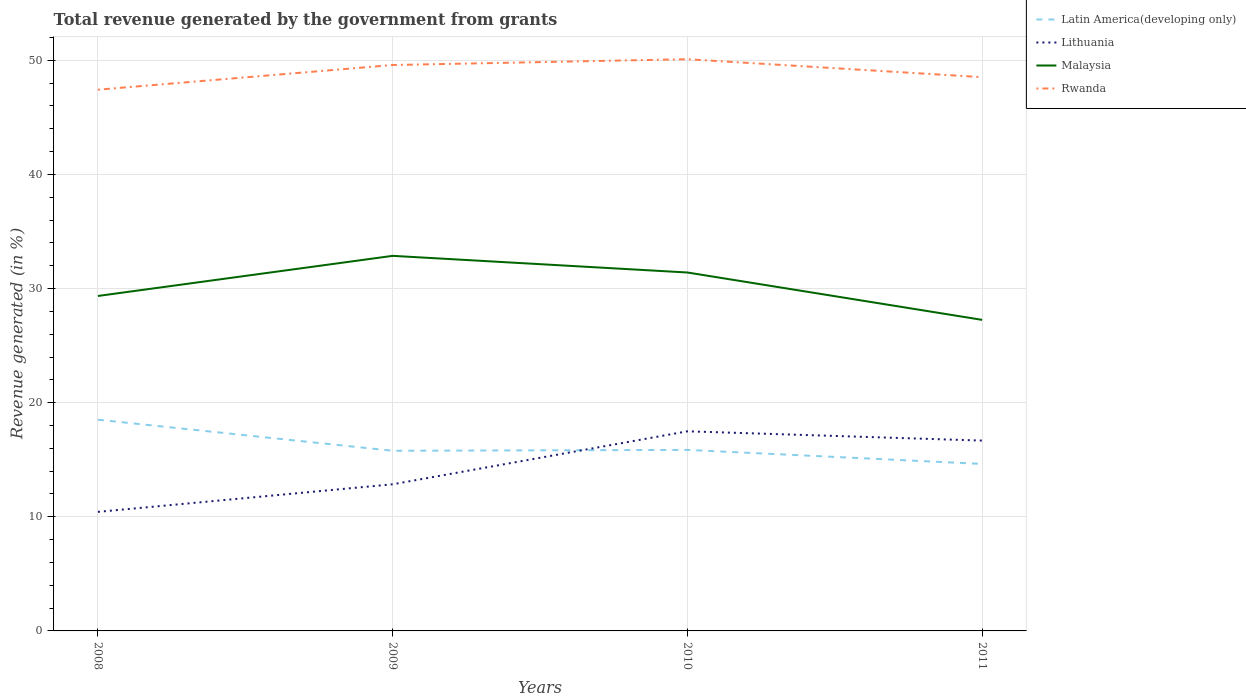Does the line corresponding to Malaysia intersect with the line corresponding to Rwanda?
Your answer should be very brief. No. Is the number of lines equal to the number of legend labels?
Give a very brief answer. Yes. Across all years, what is the maximum total revenue generated in Latin America(developing only)?
Your response must be concise. 14.63. In which year was the total revenue generated in Lithuania maximum?
Offer a very short reply. 2008. What is the total total revenue generated in Malaysia in the graph?
Your answer should be compact. 5.61. What is the difference between the highest and the second highest total revenue generated in Malaysia?
Give a very brief answer. 5.61. What is the difference between the highest and the lowest total revenue generated in Latin America(developing only)?
Offer a terse response. 1. How many lines are there?
Keep it short and to the point. 4. Are the values on the major ticks of Y-axis written in scientific E-notation?
Your answer should be compact. No. Does the graph contain any zero values?
Provide a succinct answer. No. Does the graph contain grids?
Your answer should be compact. Yes. How many legend labels are there?
Your answer should be very brief. 4. How are the legend labels stacked?
Your response must be concise. Vertical. What is the title of the graph?
Your response must be concise. Total revenue generated by the government from grants. What is the label or title of the Y-axis?
Your answer should be very brief. Revenue generated (in %). What is the Revenue generated (in %) of Latin America(developing only) in 2008?
Make the answer very short. 18.51. What is the Revenue generated (in %) in Lithuania in 2008?
Your answer should be very brief. 10.43. What is the Revenue generated (in %) in Malaysia in 2008?
Give a very brief answer. 29.35. What is the Revenue generated (in %) in Rwanda in 2008?
Your response must be concise. 47.42. What is the Revenue generated (in %) in Latin America(developing only) in 2009?
Your answer should be compact. 15.78. What is the Revenue generated (in %) of Lithuania in 2009?
Your answer should be very brief. 12.85. What is the Revenue generated (in %) in Malaysia in 2009?
Keep it short and to the point. 32.86. What is the Revenue generated (in %) in Rwanda in 2009?
Offer a terse response. 49.58. What is the Revenue generated (in %) of Latin America(developing only) in 2010?
Offer a very short reply. 15.86. What is the Revenue generated (in %) in Lithuania in 2010?
Make the answer very short. 17.49. What is the Revenue generated (in %) of Malaysia in 2010?
Offer a very short reply. 31.4. What is the Revenue generated (in %) in Rwanda in 2010?
Provide a succinct answer. 50.09. What is the Revenue generated (in %) in Latin America(developing only) in 2011?
Provide a short and direct response. 14.63. What is the Revenue generated (in %) of Lithuania in 2011?
Your response must be concise. 16.68. What is the Revenue generated (in %) in Malaysia in 2011?
Ensure brevity in your answer.  27.25. What is the Revenue generated (in %) in Rwanda in 2011?
Your answer should be very brief. 48.52. Across all years, what is the maximum Revenue generated (in %) of Latin America(developing only)?
Provide a succinct answer. 18.51. Across all years, what is the maximum Revenue generated (in %) in Lithuania?
Your answer should be very brief. 17.49. Across all years, what is the maximum Revenue generated (in %) of Malaysia?
Make the answer very short. 32.86. Across all years, what is the maximum Revenue generated (in %) in Rwanda?
Provide a succinct answer. 50.09. Across all years, what is the minimum Revenue generated (in %) in Latin America(developing only)?
Your answer should be compact. 14.63. Across all years, what is the minimum Revenue generated (in %) in Lithuania?
Provide a succinct answer. 10.43. Across all years, what is the minimum Revenue generated (in %) in Malaysia?
Offer a very short reply. 27.25. Across all years, what is the minimum Revenue generated (in %) of Rwanda?
Your answer should be compact. 47.42. What is the total Revenue generated (in %) of Latin America(developing only) in the graph?
Keep it short and to the point. 64.78. What is the total Revenue generated (in %) in Lithuania in the graph?
Give a very brief answer. 57.45. What is the total Revenue generated (in %) in Malaysia in the graph?
Provide a short and direct response. 120.87. What is the total Revenue generated (in %) in Rwanda in the graph?
Your response must be concise. 195.62. What is the difference between the Revenue generated (in %) in Latin America(developing only) in 2008 and that in 2009?
Your answer should be compact. 2.72. What is the difference between the Revenue generated (in %) in Lithuania in 2008 and that in 2009?
Give a very brief answer. -2.42. What is the difference between the Revenue generated (in %) of Malaysia in 2008 and that in 2009?
Give a very brief answer. -3.52. What is the difference between the Revenue generated (in %) in Rwanda in 2008 and that in 2009?
Make the answer very short. -2.16. What is the difference between the Revenue generated (in %) in Latin America(developing only) in 2008 and that in 2010?
Your answer should be very brief. 2.65. What is the difference between the Revenue generated (in %) in Lithuania in 2008 and that in 2010?
Give a very brief answer. -7.06. What is the difference between the Revenue generated (in %) of Malaysia in 2008 and that in 2010?
Offer a very short reply. -2.06. What is the difference between the Revenue generated (in %) of Rwanda in 2008 and that in 2010?
Keep it short and to the point. -2.67. What is the difference between the Revenue generated (in %) of Latin America(developing only) in 2008 and that in 2011?
Make the answer very short. 3.88. What is the difference between the Revenue generated (in %) of Lithuania in 2008 and that in 2011?
Provide a short and direct response. -6.24. What is the difference between the Revenue generated (in %) of Malaysia in 2008 and that in 2011?
Give a very brief answer. 2.09. What is the difference between the Revenue generated (in %) of Rwanda in 2008 and that in 2011?
Give a very brief answer. -1.1. What is the difference between the Revenue generated (in %) in Latin America(developing only) in 2009 and that in 2010?
Give a very brief answer. -0.08. What is the difference between the Revenue generated (in %) in Lithuania in 2009 and that in 2010?
Make the answer very short. -4.64. What is the difference between the Revenue generated (in %) of Malaysia in 2009 and that in 2010?
Offer a very short reply. 1.46. What is the difference between the Revenue generated (in %) of Rwanda in 2009 and that in 2010?
Ensure brevity in your answer.  -0.51. What is the difference between the Revenue generated (in %) in Latin America(developing only) in 2009 and that in 2011?
Your answer should be compact. 1.15. What is the difference between the Revenue generated (in %) of Lithuania in 2009 and that in 2011?
Your answer should be compact. -3.83. What is the difference between the Revenue generated (in %) in Malaysia in 2009 and that in 2011?
Offer a very short reply. 5.61. What is the difference between the Revenue generated (in %) in Rwanda in 2009 and that in 2011?
Your answer should be compact. 1.06. What is the difference between the Revenue generated (in %) of Latin America(developing only) in 2010 and that in 2011?
Provide a short and direct response. 1.23. What is the difference between the Revenue generated (in %) in Lithuania in 2010 and that in 2011?
Give a very brief answer. 0.81. What is the difference between the Revenue generated (in %) of Malaysia in 2010 and that in 2011?
Keep it short and to the point. 4.15. What is the difference between the Revenue generated (in %) in Rwanda in 2010 and that in 2011?
Your answer should be very brief. 1.57. What is the difference between the Revenue generated (in %) in Latin America(developing only) in 2008 and the Revenue generated (in %) in Lithuania in 2009?
Provide a short and direct response. 5.66. What is the difference between the Revenue generated (in %) of Latin America(developing only) in 2008 and the Revenue generated (in %) of Malaysia in 2009?
Make the answer very short. -14.36. What is the difference between the Revenue generated (in %) of Latin America(developing only) in 2008 and the Revenue generated (in %) of Rwanda in 2009?
Keep it short and to the point. -31.08. What is the difference between the Revenue generated (in %) in Lithuania in 2008 and the Revenue generated (in %) in Malaysia in 2009?
Offer a terse response. -22.43. What is the difference between the Revenue generated (in %) in Lithuania in 2008 and the Revenue generated (in %) in Rwanda in 2009?
Keep it short and to the point. -39.15. What is the difference between the Revenue generated (in %) in Malaysia in 2008 and the Revenue generated (in %) in Rwanda in 2009?
Make the answer very short. -20.24. What is the difference between the Revenue generated (in %) of Latin America(developing only) in 2008 and the Revenue generated (in %) of Lithuania in 2010?
Keep it short and to the point. 1.02. What is the difference between the Revenue generated (in %) of Latin America(developing only) in 2008 and the Revenue generated (in %) of Malaysia in 2010?
Your answer should be compact. -12.9. What is the difference between the Revenue generated (in %) in Latin America(developing only) in 2008 and the Revenue generated (in %) in Rwanda in 2010?
Provide a succinct answer. -31.59. What is the difference between the Revenue generated (in %) in Lithuania in 2008 and the Revenue generated (in %) in Malaysia in 2010?
Make the answer very short. -20.97. What is the difference between the Revenue generated (in %) of Lithuania in 2008 and the Revenue generated (in %) of Rwanda in 2010?
Your response must be concise. -39.66. What is the difference between the Revenue generated (in %) of Malaysia in 2008 and the Revenue generated (in %) of Rwanda in 2010?
Offer a very short reply. -20.74. What is the difference between the Revenue generated (in %) of Latin America(developing only) in 2008 and the Revenue generated (in %) of Lithuania in 2011?
Keep it short and to the point. 1.83. What is the difference between the Revenue generated (in %) of Latin America(developing only) in 2008 and the Revenue generated (in %) of Malaysia in 2011?
Give a very brief answer. -8.75. What is the difference between the Revenue generated (in %) in Latin America(developing only) in 2008 and the Revenue generated (in %) in Rwanda in 2011?
Provide a short and direct response. -30.01. What is the difference between the Revenue generated (in %) of Lithuania in 2008 and the Revenue generated (in %) of Malaysia in 2011?
Your response must be concise. -16.82. What is the difference between the Revenue generated (in %) in Lithuania in 2008 and the Revenue generated (in %) in Rwanda in 2011?
Your answer should be compact. -38.09. What is the difference between the Revenue generated (in %) of Malaysia in 2008 and the Revenue generated (in %) of Rwanda in 2011?
Your answer should be very brief. -19.17. What is the difference between the Revenue generated (in %) in Latin America(developing only) in 2009 and the Revenue generated (in %) in Lithuania in 2010?
Make the answer very short. -1.71. What is the difference between the Revenue generated (in %) of Latin America(developing only) in 2009 and the Revenue generated (in %) of Malaysia in 2010?
Offer a very short reply. -15.62. What is the difference between the Revenue generated (in %) in Latin America(developing only) in 2009 and the Revenue generated (in %) in Rwanda in 2010?
Ensure brevity in your answer.  -34.31. What is the difference between the Revenue generated (in %) of Lithuania in 2009 and the Revenue generated (in %) of Malaysia in 2010?
Your response must be concise. -18.56. What is the difference between the Revenue generated (in %) in Lithuania in 2009 and the Revenue generated (in %) in Rwanda in 2010?
Make the answer very short. -37.24. What is the difference between the Revenue generated (in %) in Malaysia in 2009 and the Revenue generated (in %) in Rwanda in 2010?
Give a very brief answer. -17.23. What is the difference between the Revenue generated (in %) of Latin America(developing only) in 2009 and the Revenue generated (in %) of Lithuania in 2011?
Keep it short and to the point. -0.89. What is the difference between the Revenue generated (in %) in Latin America(developing only) in 2009 and the Revenue generated (in %) in Malaysia in 2011?
Your answer should be very brief. -11.47. What is the difference between the Revenue generated (in %) of Latin America(developing only) in 2009 and the Revenue generated (in %) of Rwanda in 2011?
Your answer should be compact. -32.73. What is the difference between the Revenue generated (in %) in Lithuania in 2009 and the Revenue generated (in %) in Malaysia in 2011?
Keep it short and to the point. -14.41. What is the difference between the Revenue generated (in %) in Lithuania in 2009 and the Revenue generated (in %) in Rwanda in 2011?
Provide a succinct answer. -35.67. What is the difference between the Revenue generated (in %) in Malaysia in 2009 and the Revenue generated (in %) in Rwanda in 2011?
Offer a terse response. -15.65. What is the difference between the Revenue generated (in %) in Latin America(developing only) in 2010 and the Revenue generated (in %) in Lithuania in 2011?
Ensure brevity in your answer.  -0.81. What is the difference between the Revenue generated (in %) of Latin America(developing only) in 2010 and the Revenue generated (in %) of Malaysia in 2011?
Provide a succinct answer. -11.39. What is the difference between the Revenue generated (in %) of Latin America(developing only) in 2010 and the Revenue generated (in %) of Rwanda in 2011?
Offer a very short reply. -32.66. What is the difference between the Revenue generated (in %) in Lithuania in 2010 and the Revenue generated (in %) in Malaysia in 2011?
Offer a very short reply. -9.76. What is the difference between the Revenue generated (in %) in Lithuania in 2010 and the Revenue generated (in %) in Rwanda in 2011?
Offer a very short reply. -31.03. What is the difference between the Revenue generated (in %) of Malaysia in 2010 and the Revenue generated (in %) of Rwanda in 2011?
Provide a short and direct response. -17.11. What is the average Revenue generated (in %) of Latin America(developing only) per year?
Your answer should be compact. 16.2. What is the average Revenue generated (in %) of Lithuania per year?
Keep it short and to the point. 14.36. What is the average Revenue generated (in %) of Malaysia per year?
Your answer should be compact. 30.22. What is the average Revenue generated (in %) in Rwanda per year?
Offer a terse response. 48.9. In the year 2008, what is the difference between the Revenue generated (in %) of Latin America(developing only) and Revenue generated (in %) of Lithuania?
Offer a terse response. 8.08. In the year 2008, what is the difference between the Revenue generated (in %) in Latin America(developing only) and Revenue generated (in %) in Malaysia?
Offer a very short reply. -10.84. In the year 2008, what is the difference between the Revenue generated (in %) of Latin America(developing only) and Revenue generated (in %) of Rwanda?
Make the answer very short. -28.91. In the year 2008, what is the difference between the Revenue generated (in %) of Lithuania and Revenue generated (in %) of Malaysia?
Give a very brief answer. -18.92. In the year 2008, what is the difference between the Revenue generated (in %) of Lithuania and Revenue generated (in %) of Rwanda?
Provide a short and direct response. -36.99. In the year 2008, what is the difference between the Revenue generated (in %) in Malaysia and Revenue generated (in %) in Rwanda?
Offer a very short reply. -18.07. In the year 2009, what is the difference between the Revenue generated (in %) of Latin America(developing only) and Revenue generated (in %) of Lithuania?
Your answer should be compact. 2.94. In the year 2009, what is the difference between the Revenue generated (in %) in Latin America(developing only) and Revenue generated (in %) in Malaysia?
Offer a very short reply. -17.08. In the year 2009, what is the difference between the Revenue generated (in %) of Latin America(developing only) and Revenue generated (in %) of Rwanda?
Offer a very short reply. -33.8. In the year 2009, what is the difference between the Revenue generated (in %) in Lithuania and Revenue generated (in %) in Malaysia?
Offer a terse response. -20.02. In the year 2009, what is the difference between the Revenue generated (in %) of Lithuania and Revenue generated (in %) of Rwanda?
Ensure brevity in your answer.  -36.74. In the year 2009, what is the difference between the Revenue generated (in %) of Malaysia and Revenue generated (in %) of Rwanda?
Your answer should be compact. -16.72. In the year 2010, what is the difference between the Revenue generated (in %) of Latin America(developing only) and Revenue generated (in %) of Lithuania?
Make the answer very short. -1.63. In the year 2010, what is the difference between the Revenue generated (in %) in Latin America(developing only) and Revenue generated (in %) in Malaysia?
Offer a terse response. -15.54. In the year 2010, what is the difference between the Revenue generated (in %) in Latin America(developing only) and Revenue generated (in %) in Rwanda?
Provide a succinct answer. -34.23. In the year 2010, what is the difference between the Revenue generated (in %) in Lithuania and Revenue generated (in %) in Malaysia?
Offer a terse response. -13.91. In the year 2010, what is the difference between the Revenue generated (in %) in Lithuania and Revenue generated (in %) in Rwanda?
Offer a very short reply. -32.6. In the year 2010, what is the difference between the Revenue generated (in %) in Malaysia and Revenue generated (in %) in Rwanda?
Provide a succinct answer. -18.69. In the year 2011, what is the difference between the Revenue generated (in %) of Latin America(developing only) and Revenue generated (in %) of Lithuania?
Make the answer very short. -2.05. In the year 2011, what is the difference between the Revenue generated (in %) in Latin America(developing only) and Revenue generated (in %) in Malaysia?
Ensure brevity in your answer.  -12.62. In the year 2011, what is the difference between the Revenue generated (in %) in Latin America(developing only) and Revenue generated (in %) in Rwanda?
Ensure brevity in your answer.  -33.89. In the year 2011, what is the difference between the Revenue generated (in %) in Lithuania and Revenue generated (in %) in Malaysia?
Your response must be concise. -10.58. In the year 2011, what is the difference between the Revenue generated (in %) in Lithuania and Revenue generated (in %) in Rwanda?
Give a very brief answer. -31.84. In the year 2011, what is the difference between the Revenue generated (in %) in Malaysia and Revenue generated (in %) in Rwanda?
Keep it short and to the point. -21.26. What is the ratio of the Revenue generated (in %) of Latin America(developing only) in 2008 to that in 2009?
Your answer should be compact. 1.17. What is the ratio of the Revenue generated (in %) in Lithuania in 2008 to that in 2009?
Provide a short and direct response. 0.81. What is the ratio of the Revenue generated (in %) of Malaysia in 2008 to that in 2009?
Ensure brevity in your answer.  0.89. What is the ratio of the Revenue generated (in %) of Rwanda in 2008 to that in 2009?
Your answer should be compact. 0.96. What is the ratio of the Revenue generated (in %) of Latin America(developing only) in 2008 to that in 2010?
Your answer should be very brief. 1.17. What is the ratio of the Revenue generated (in %) of Lithuania in 2008 to that in 2010?
Your response must be concise. 0.6. What is the ratio of the Revenue generated (in %) in Malaysia in 2008 to that in 2010?
Provide a short and direct response. 0.93. What is the ratio of the Revenue generated (in %) of Rwanda in 2008 to that in 2010?
Your answer should be compact. 0.95. What is the ratio of the Revenue generated (in %) of Latin America(developing only) in 2008 to that in 2011?
Ensure brevity in your answer.  1.26. What is the ratio of the Revenue generated (in %) in Lithuania in 2008 to that in 2011?
Provide a short and direct response. 0.63. What is the ratio of the Revenue generated (in %) in Malaysia in 2008 to that in 2011?
Your answer should be very brief. 1.08. What is the ratio of the Revenue generated (in %) in Rwanda in 2008 to that in 2011?
Provide a succinct answer. 0.98. What is the ratio of the Revenue generated (in %) of Latin America(developing only) in 2009 to that in 2010?
Offer a very short reply. 1. What is the ratio of the Revenue generated (in %) of Lithuania in 2009 to that in 2010?
Offer a very short reply. 0.73. What is the ratio of the Revenue generated (in %) of Malaysia in 2009 to that in 2010?
Offer a very short reply. 1.05. What is the ratio of the Revenue generated (in %) in Latin America(developing only) in 2009 to that in 2011?
Offer a very short reply. 1.08. What is the ratio of the Revenue generated (in %) in Lithuania in 2009 to that in 2011?
Your answer should be very brief. 0.77. What is the ratio of the Revenue generated (in %) in Malaysia in 2009 to that in 2011?
Your answer should be compact. 1.21. What is the ratio of the Revenue generated (in %) in Rwanda in 2009 to that in 2011?
Provide a succinct answer. 1.02. What is the ratio of the Revenue generated (in %) in Latin America(developing only) in 2010 to that in 2011?
Offer a terse response. 1.08. What is the ratio of the Revenue generated (in %) of Lithuania in 2010 to that in 2011?
Offer a very short reply. 1.05. What is the ratio of the Revenue generated (in %) of Malaysia in 2010 to that in 2011?
Make the answer very short. 1.15. What is the ratio of the Revenue generated (in %) in Rwanda in 2010 to that in 2011?
Offer a very short reply. 1.03. What is the difference between the highest and the second highest Revenue generated (in %) in Latin America(developing only)?
Provide a succinct answer. 2.65. What is the difference between the highest and the second highest Revenue generated (in %) in Lithuania?
Your response must be concise. 0.81. What is the difference between the highest and the second highest Revenue generated (in %) of Malaysia?
Provide a short and direct response. 1.46. What is the difference between the highest and the second highest Revenue generated (in %) of Rwanda?
Provide a succinct answer. 0.51. What is the difference between the highest and the lowest Revenue generated (in %) in Latin America(developing only)?
Give a very brief answer. 3.88. What is the difference between the highest and the lowest Revenue generated (in %) of Lithuania?
Make the answer very short. 7.06. What is the difference between the highest and the lowest Revenue generated (in %) of Malaysia?
Make the answer very short. 5.61. What is the difference between the highest and the lowest Revenue generated (in %) in Rwanda?
Offer a very short reply. 2.67. 